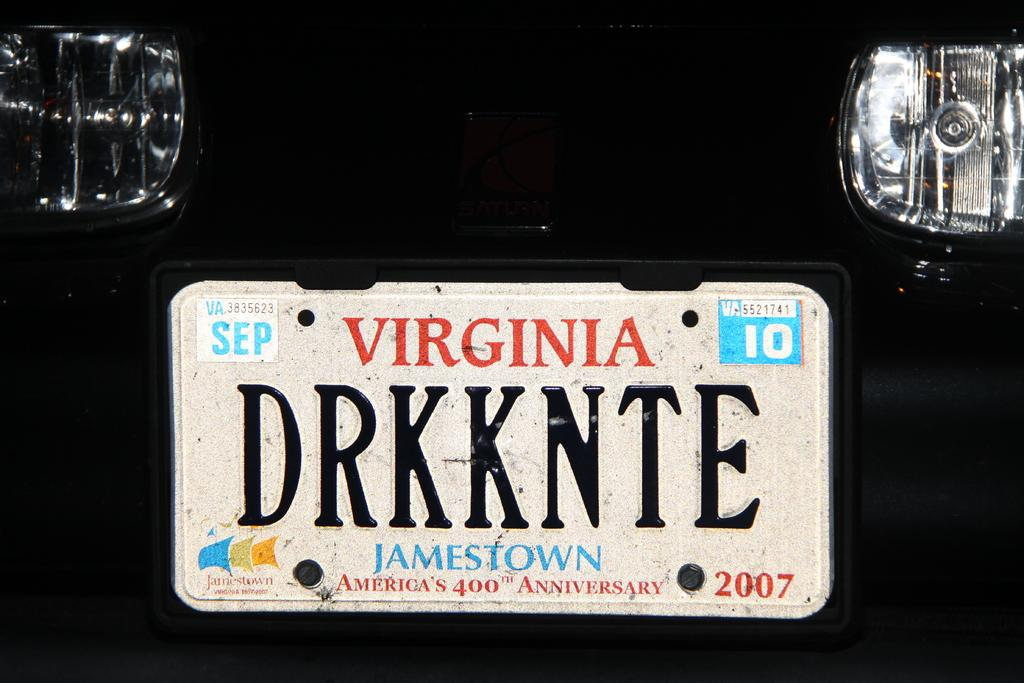What can be seen in the image that emits light? There are lights in the image. What is the main object in the image that is used for writing or displaying information? There is a white color board in the image. What is written or displayed on the white color board? Something is written on the white color board. What is the color of the background in the image? The background of the image is black in color. What degree of difficulty is assigned to the scale in the image? There is no scale or degree of difficulty present in the image. What position does the person holding the white color board have in the image? There is no person holding the white color board in the image; it is stationary. 